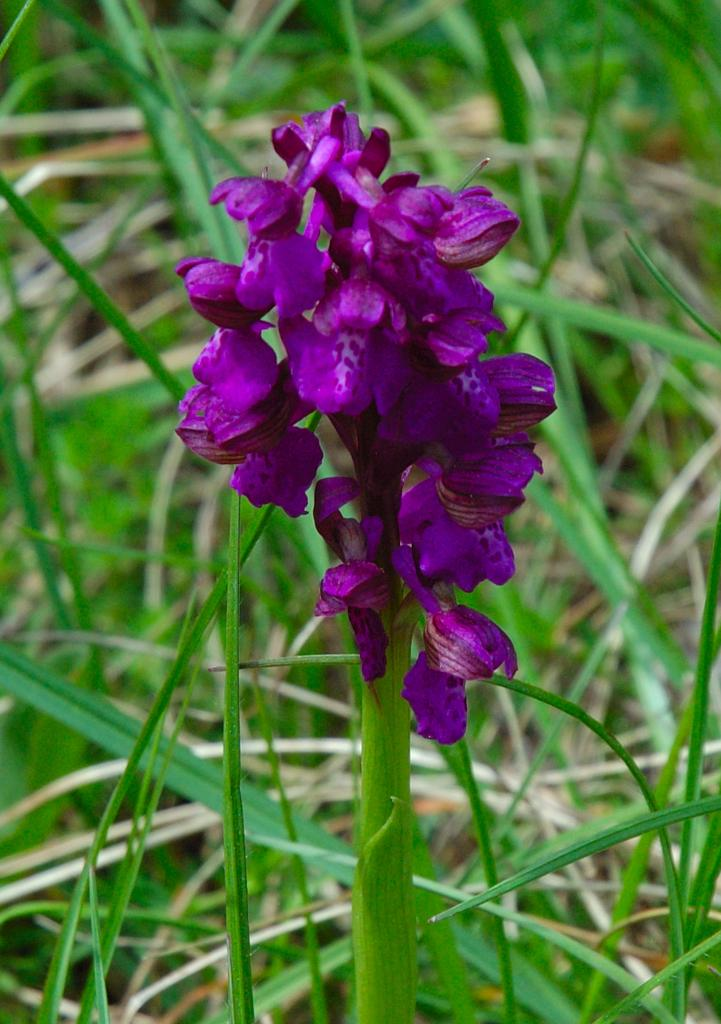Where was the image taken? The image was taken outdoors. What can be seen on the ground in the background of the image? There is grass on the ground in the background. What is the main subject in the middle of the image? There is a plant in the middle of the image. What is special about the plant in the image? The plant has beautiful purple flowers on it. How does the boy interact with the dust in the image? There is no boy or dust present in the image. What is the view like from the top of the plant in the image? The image does not provide a view from the top of the plant, as it is taken from a different perspective. 